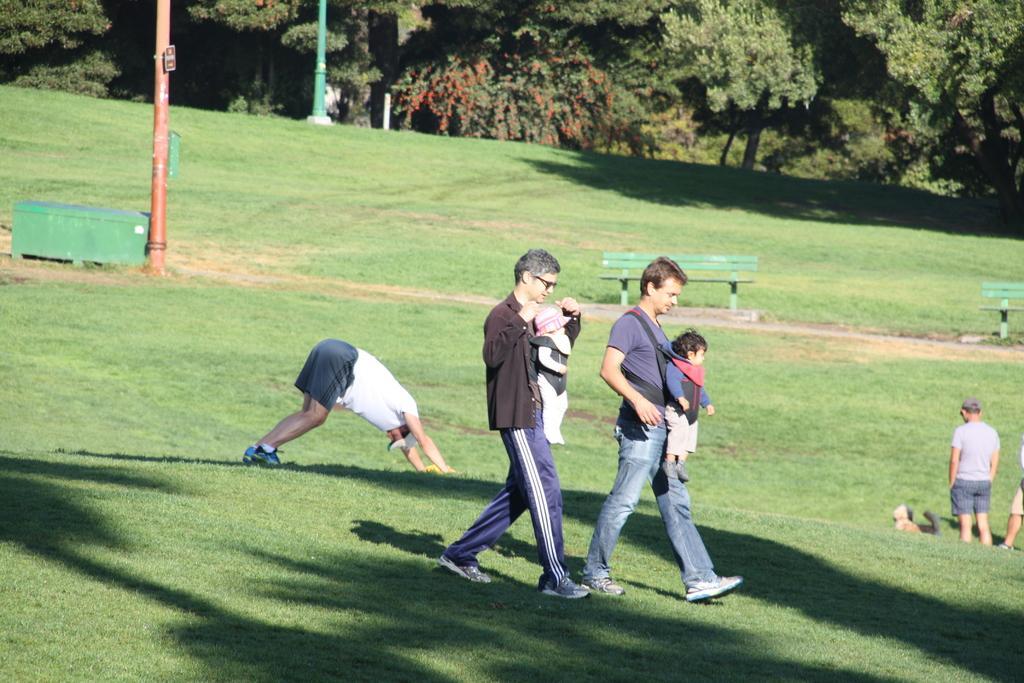Can you describe this image briefly? In the foreground of the image there are two people carrying babies and walking on the grass. In the background of the image there are people. There are benches, poles. In the background there are trees. At the bottom of the image there is grass. 